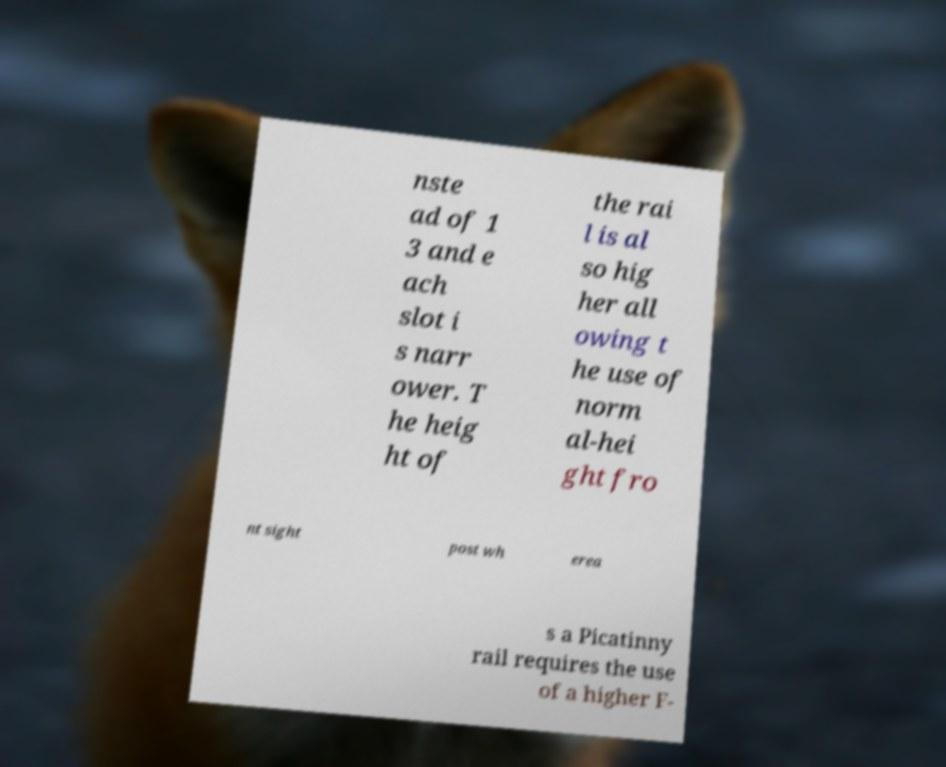There's text embedded in this image that I need extracted. Can you transcribe it verbatim? nste ad of 1 3 and e ach slot i s narr ower. T he heig ht of the rai l is al so hig her all owing t he use of norm al-hei ght fro nt sight post wh erea s a Picatinny rail requires the use of a higher F- 